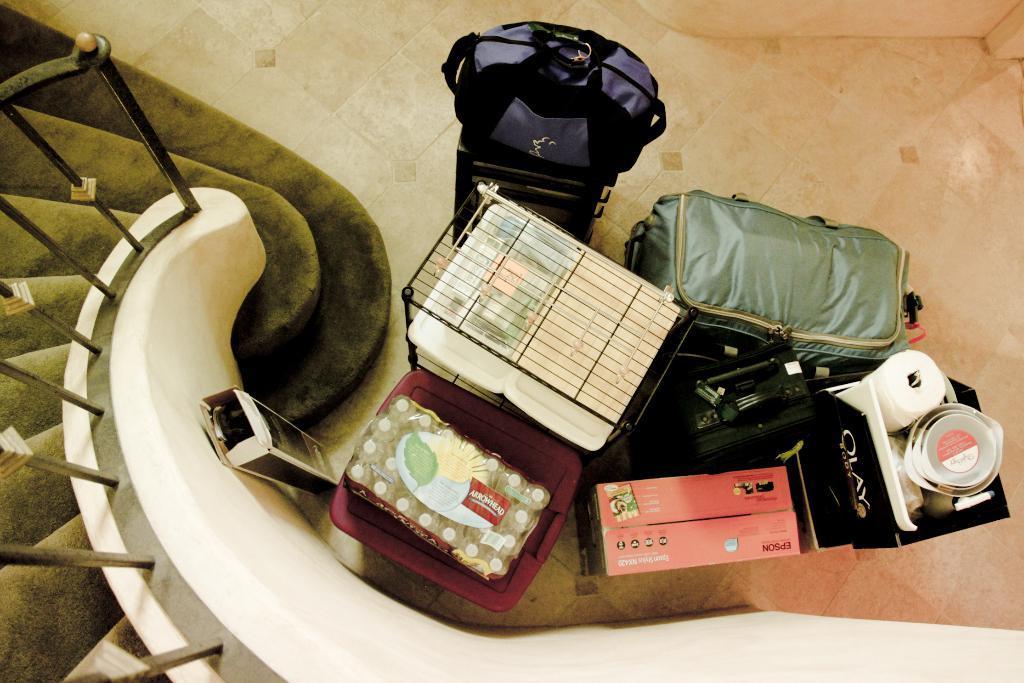Can you describe this image briefly? In this picture we can see luggage with boxes, suitcase, net, bags and here we can see tissue paper and bowls. These are of bottles package and here are steps with fence. 